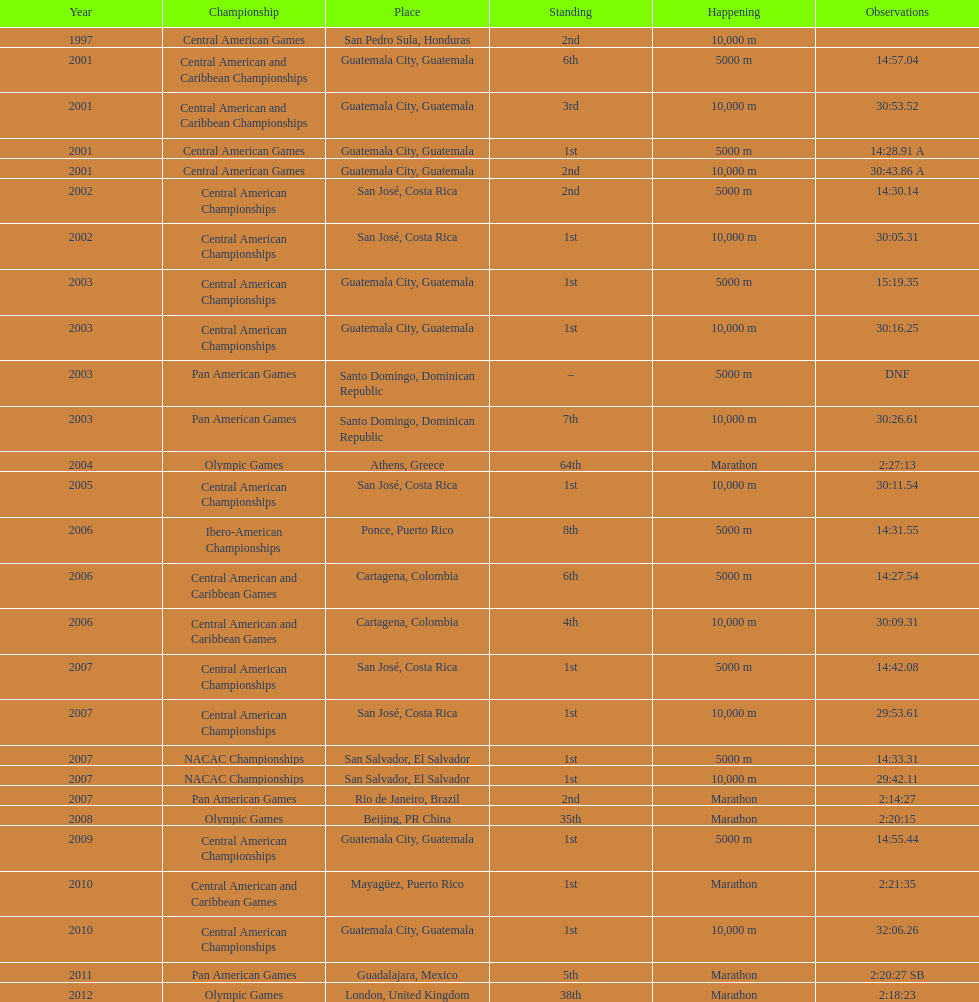The central american championships and what other competition occurred in 2010? Central American and Caribbean Games. 